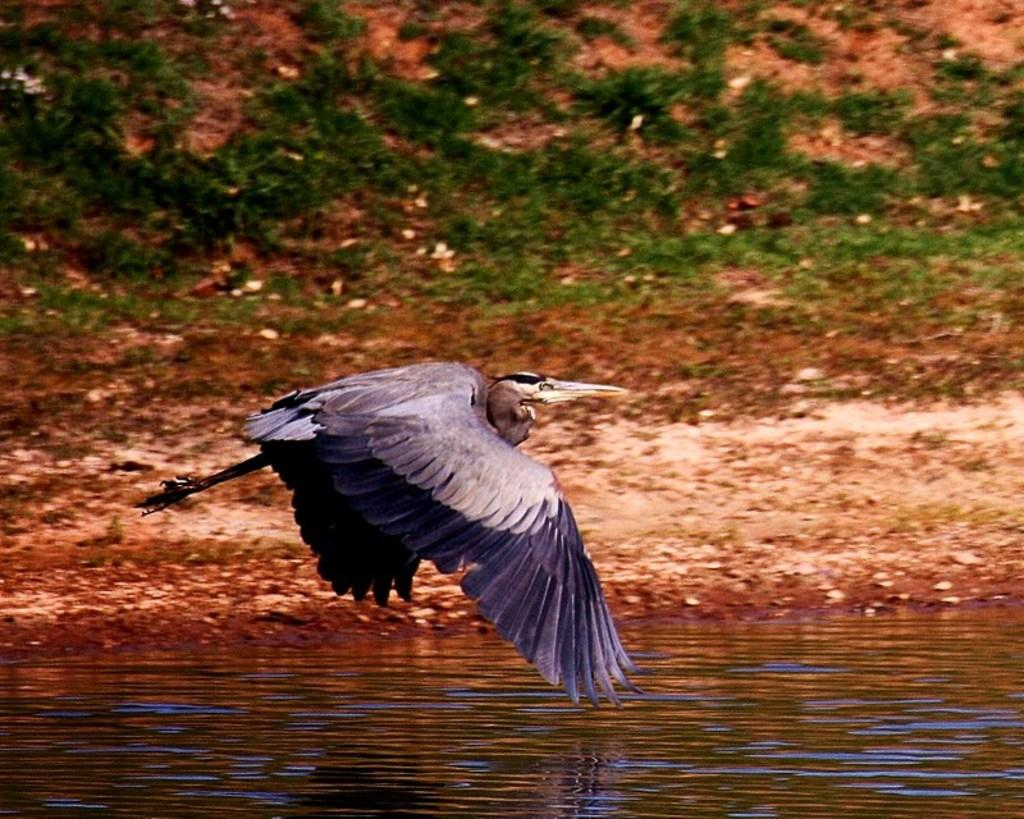What is the main subject of the image? There is a bird flying in the image. Where is the bird located in the image? The bird is in the middle of the image. What is visible at the bottom of the image? There is water at the bottom of the image. What type of vegetation can be seen in the background of the image? There is grass in the background of the image. What else can be seen in the background of the image? There is land in the background of the image. Can you tell me how many combs are being used by the bird in the image? There are no combs present in the image; it features a bird flying. What type of skate is the bird using to fly in the image? There is no skate present in the image; the bird is flying naturally. 